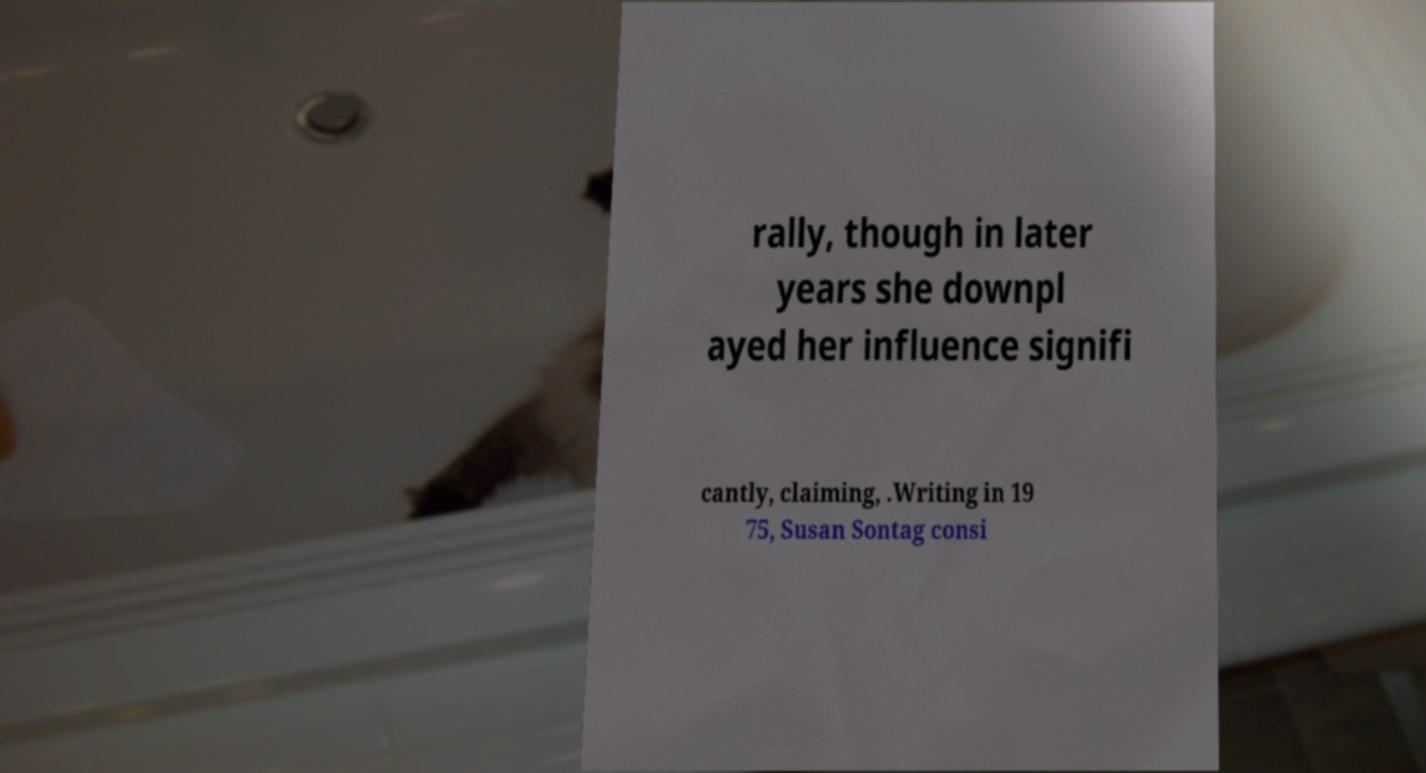Could you extract and type out the text from this image? rally, though in later years she downpl ayed her influence signifi cantly, claiming, .Writing in 19 75, Susan Sontag consi 